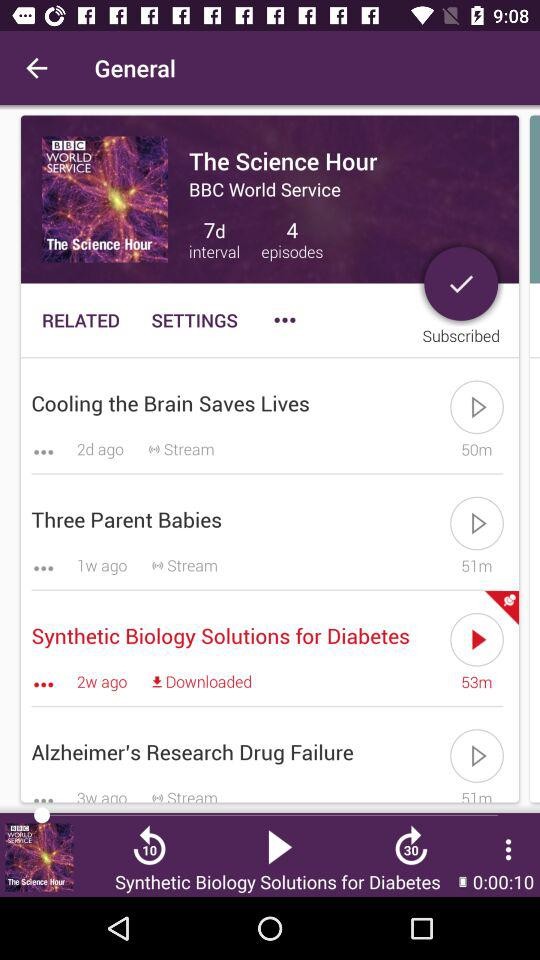What is the number of episodes? The number of episodes is 4. 